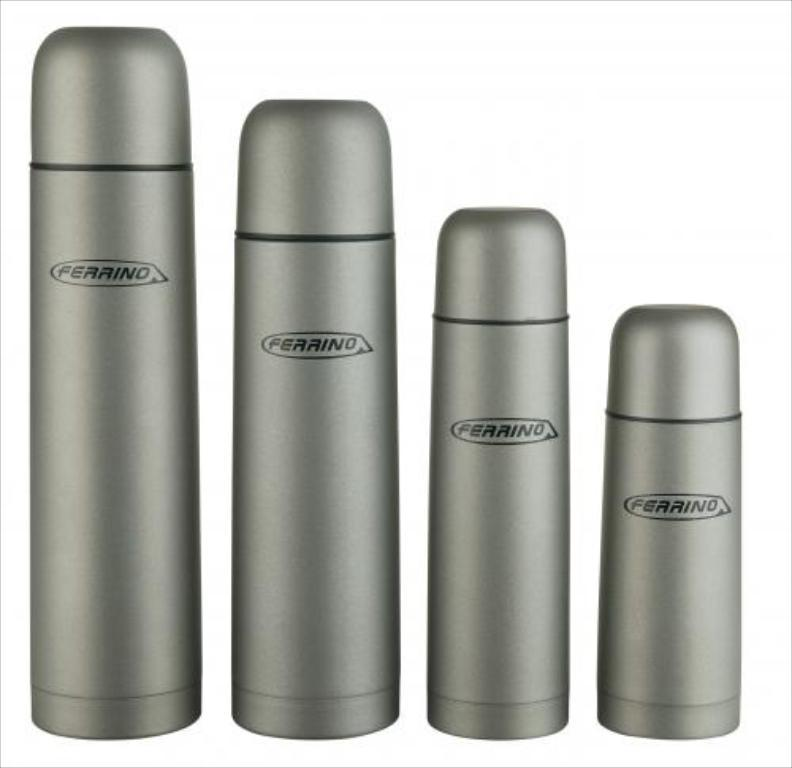<image>
Render a clear and concise summary of the photo. Four Ferrino bottles of decreasing size are arranged next to one another. 